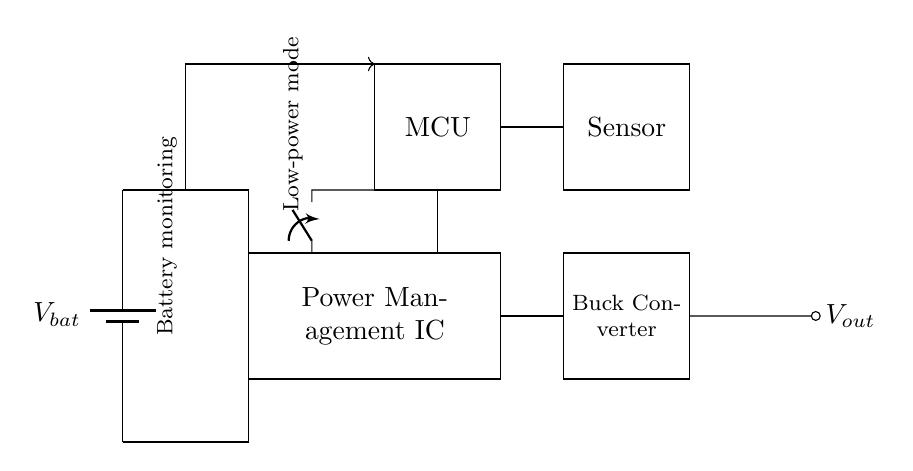What is the main function of the power management IC? The power management IC regulates the power supplied to the mobile device, ensuring that the components receive the appropriate voltage and current for optimal operation.
Answer: Regulates power How many components are there that have the potential to draw current from the battery? The circuit has three main components that can draw current from the battery: the power management IC, the microcontroller, and the sensor. Each component requires power to function.
Answer: Three What kind of converter is used in this circuit? The circuit contains a buck converter which is specifically designed to step down voltage from the power management IC to the required output voltage level for the device.
Answer: Buck converter Describe the purpose of the low-power mode switch. The low-power mode switch allows the circuit to enter a reduced power state, which helps to conserve battery life when full functionality is not necessary. This switch can help in extending the overall battery life of the mobile device.
Answer: Conserves battery life How does battery monitoring connect to the rest of the circuit? The battery monitoring is connected via a direction arrow indicating the flow, which suggests that it monitors the battery's status and communicates it to the power management IC for adjustments accordingly.
Answer: Monitors status What is the output voltage denoted by in the circuit? The output voltage, labeled as V out, represents the voltage supplied to other components from the buck converter, ensuring they have the necessary voltage for operation without exceeding limits.
Answer: V out 